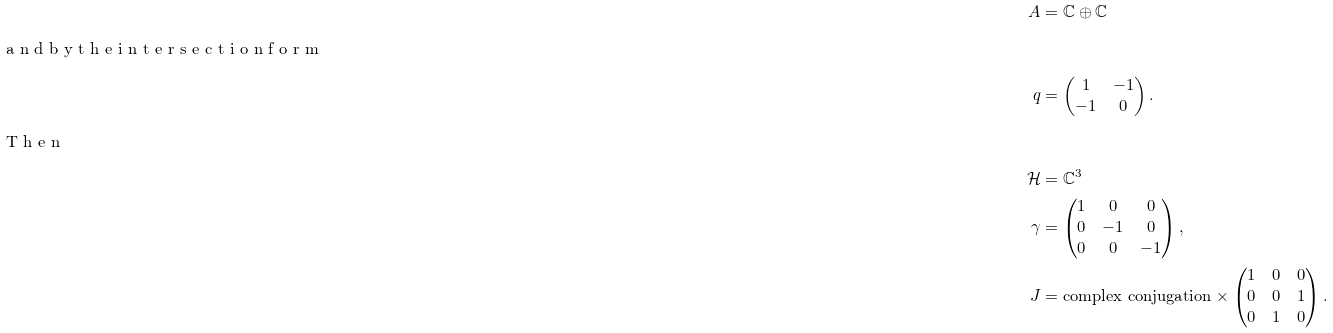<formula> <loc_0><loc_0><loc_500><loc_500>A & = \mathbb { C } \oplus \mathbb { C } \\ \intertext { a n d b y t h e i n t e r s e c t i o n f o r m } q & = \begin{pmatrix} 1 & - 1 \\ - 1 & 0 \\ \end{pmatrix} . \\ \intertext { T h e n } \mathcal { H } & = { \mathbb { C } } ^ { 3 } \\ \gamma & = \begin{pmatrix} 1 & 0 & 0 \\ 0 & - 1 & 0 \\ 0 & 0 & - 1 \end{pmatrix} , \\ J & = \text {complex conjugation} \times \begin{pmatrix} 1 & 0 & 0 \\ 0 & 0 & 1 \\ 0 & 1 & 0 \end{pmatrix} .</formula> 